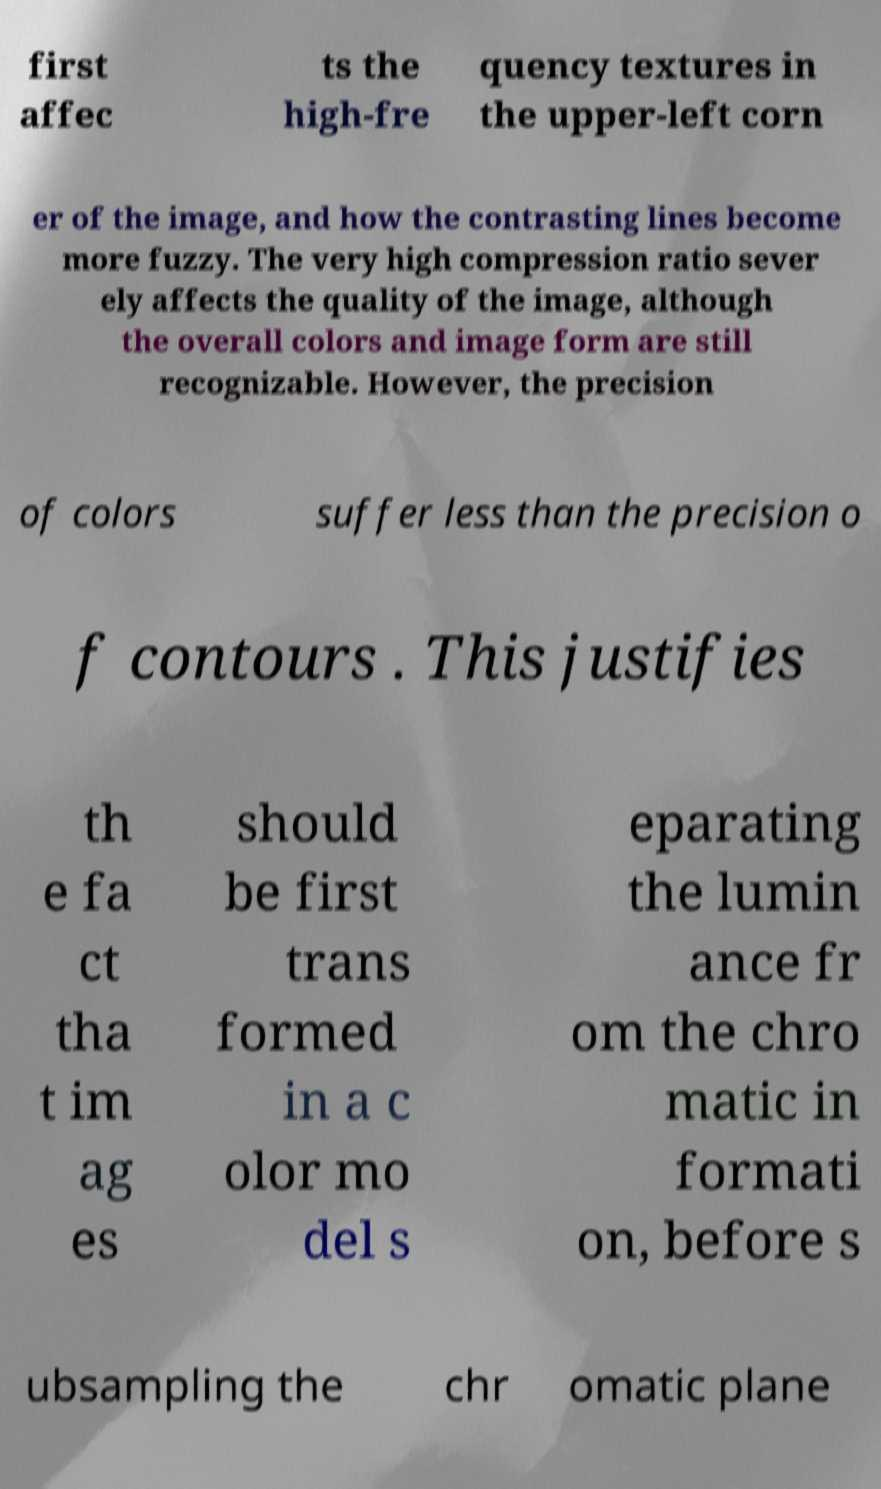Please read and relay the text visible in this image. What does it say? first affec ts the high-fre quency textures in the upper-left corn er of the image, and how the contrasting lines become more fuzzy. The very high compression ratio sever ely affects the quality of the image, although the overall colors and image form are still recognizable. However, the precision of colors suffer less than the precision o f contours . This justifies th e fa ct tha t im ag es should be first trans formed in a c olor mo del s eparating the lumin ance fr om the chro matic in formati on, before s ubsampling the chr omatic plane 